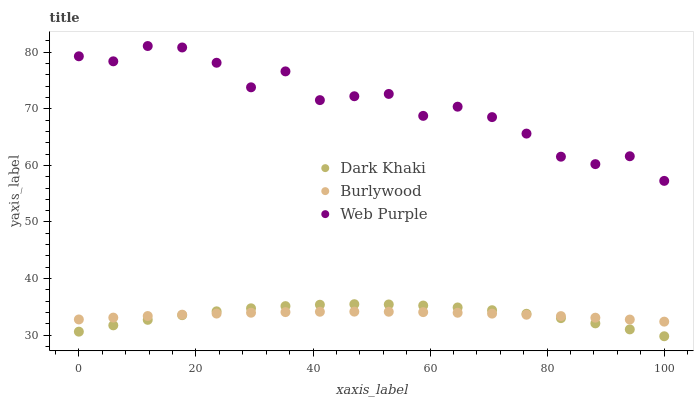Does Burlywood have the minimum area under the curve?
Answer yes or no. Yes. Does Web Purple have the maximum area under the curve?
Answer yes or no. Yes. Does Web Purple have the minimum area under the curve?
Answer yes or no. No. Does Burlywood have the maximum area under the curve?
Answer yes or no. No. Is Burlywood the smoothest?
Answer yes or no. Yes. Is Web Purple the roughest?
Answer yes or no. Yes. Is Web Purple the smoothest?
Answer yes or no. No. Is Burlywood the roughest?
Answer yes or no. No. Does Dark Khaki have the lowest value?
Answer yes or no. Yes. Does Burlywood have the lowest value?
Answer yes or no. No. Does Web Purple have the highest value?
Answer yes or no. Yes. Does Burlywood have the highest value?
Answer yes or no. No. Is Dark Khaki less than Web Purple?
Answer yes or no. Yes. Is Web Purple greater than Dark Khaki?
Answer yes or no. Yes. Does Dark Khaki intersect Burlywood?
Answer yes or no. Yes. Is Dark Khaki less than Burlywood?
Answer yes or no. No. Is Dark Khaki greater than Burlywood?
Answer yes or no. No. Does Dark Khaki intersect Web Purple?
Answer yes or no. No. 